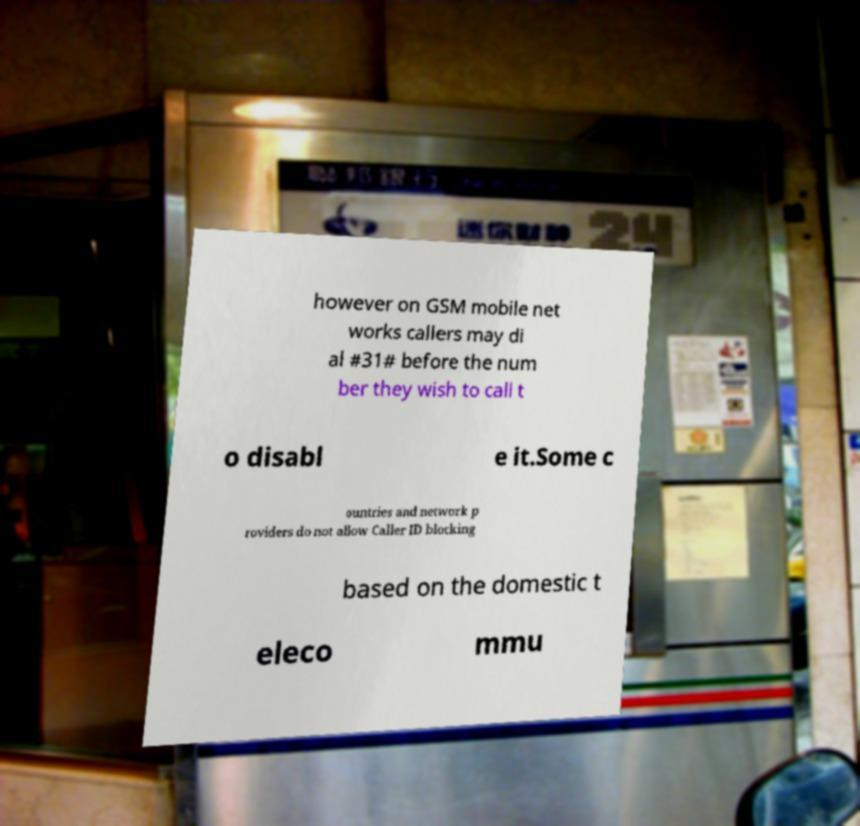Could you assist in decoding the text presented in this image and type it out clearly? however on GSM mobile net works callers may di al #31# before the num ber they wish to call t o disabl e it.Some c ountries and network p roviders do not allow Caller ID blocking based on the domestic t eleco mmu 